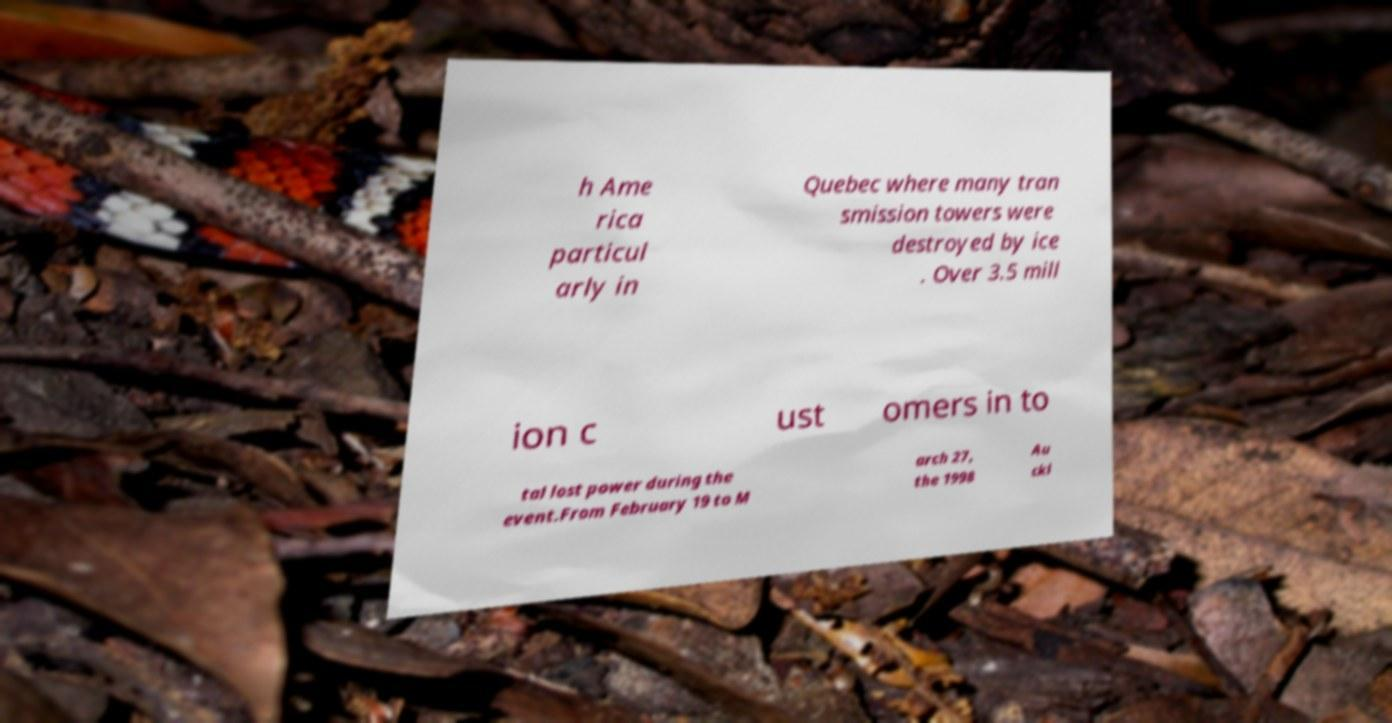Could you assist in decoding the text presented in this image and type it out clearly? h Ame rica particul arly in Quebec where many tran smission towers were destroyed by ice . Over 3.5 mill ion c ust omers in to tal lost power during the event.From February 19 to M arch 27, the 1998 Au ckl 